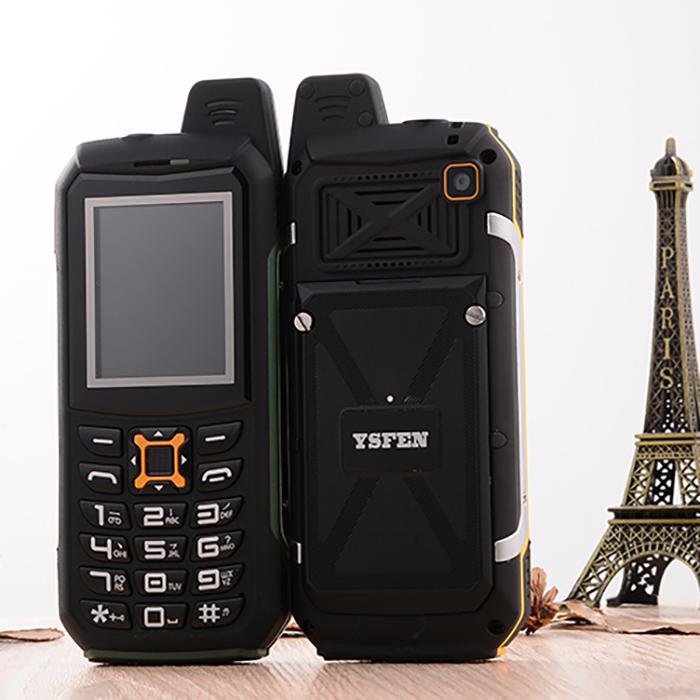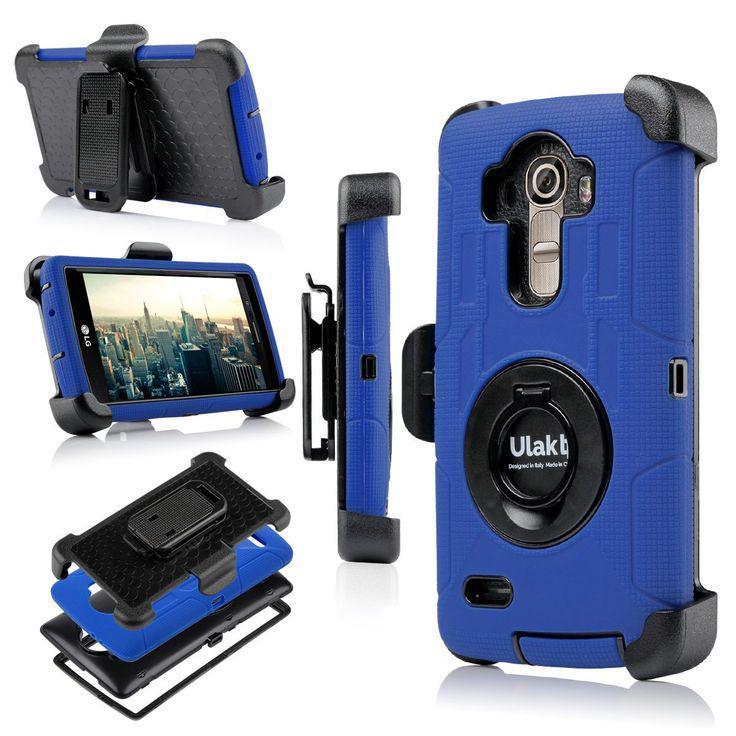The first image is the image on the left, the second image is the image on the right. Examine the images to the left and right. Is the description "One image shows a group of five items showing configurations of a device that is black and one other color, and the other image shows a rectangular device in two side-by-side views." accurate? Answer yes or no. Yes. The first image is the image on the left, the second image is the image on the right. Evaluate the accuracy of this statement regarding the images: "The right image features a profile orientation of the phone.". Is it true? Answer yes or no. Yes. 